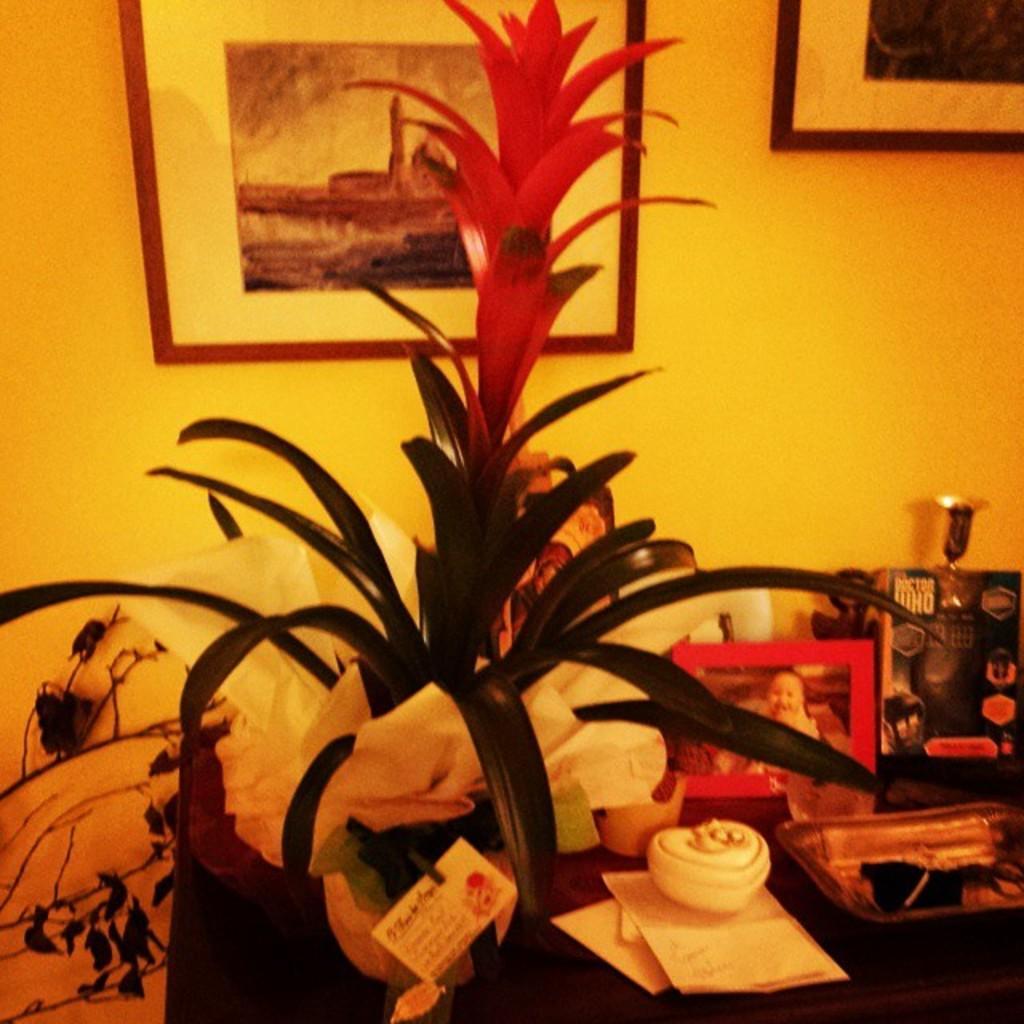Please provide a concise description of this image. In this image, at the bottom there is a table on that there are papers, posters, box, plant, tissues, photo frame, some objects, toys. In the background there are photo frames and a wall. 